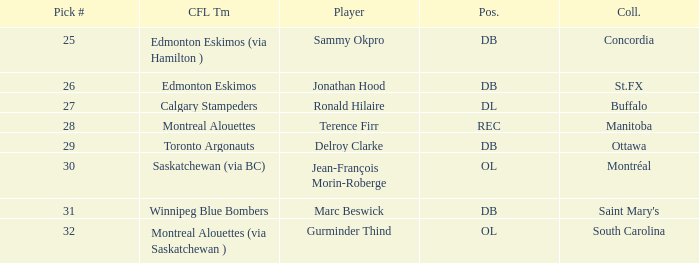What is buffalo's pick #? 27.0. Can you give me this table as a dict? {'header': ['Pick #', 'CFL Tm', 'Player', 'Pos.', 'Coll.'], 'rows': [['25', 'Edmonton Eskimos (via Hamilton )', 'Sammy Okpro', 'DB', 'Concordia'], ['26', 'Edmonton Eskimos', 'Jonathan Hood', 'DB', 'St.FX'], ['27', 'Calgary Stampeders', 'Ronald Hilaire', 'DL', 'Buffalo'], ['28', 'Montreal Alouettes', 'Terence Firr', 'REC', 'Manitoba'], ['29', 'Toronto Argonauts', 'Delroy Clarke', 'DB', 'Ottawa'], ['30', 'Saskatchewan (via BC)', 'Jean-François Morin-Roberge', 'OL', 'Montréal'], ['31', 'Winnipeg Blue Bombers', 'Marc Beswick', 'DB', "Saint Mary's"], ['32', 'Montreal Alouettes (via Saskatchewan )', 'Gurminder Thind', 'OL', 'South Carolina']]} 